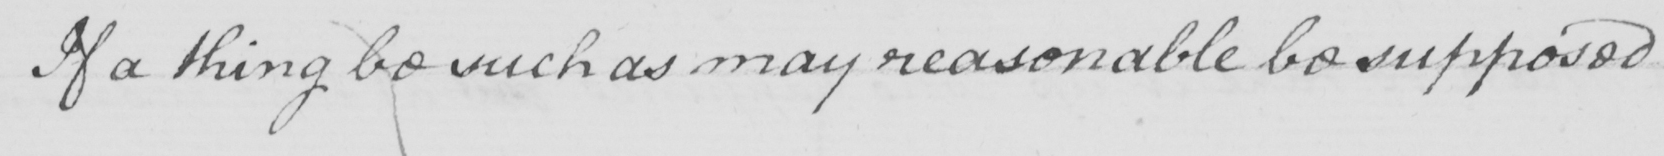Transcribe the text shown in this historical manuscript line. If a thing be such as may reasonable be supposed 